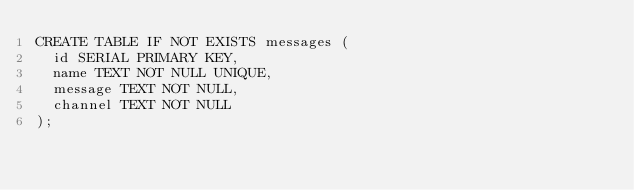Convert code to text. <code><loc_0><loc_0><loc_500><loc_500><_SQL_>CREATE TABLE IF NOT EXISTS messages (
  id SERIAL PRIMARY KEY,
  name TEXT NOT NULL UNIQUE,
  message TEXT NOT NULL,
  channel TEXT NOT NULL
);
</code> 